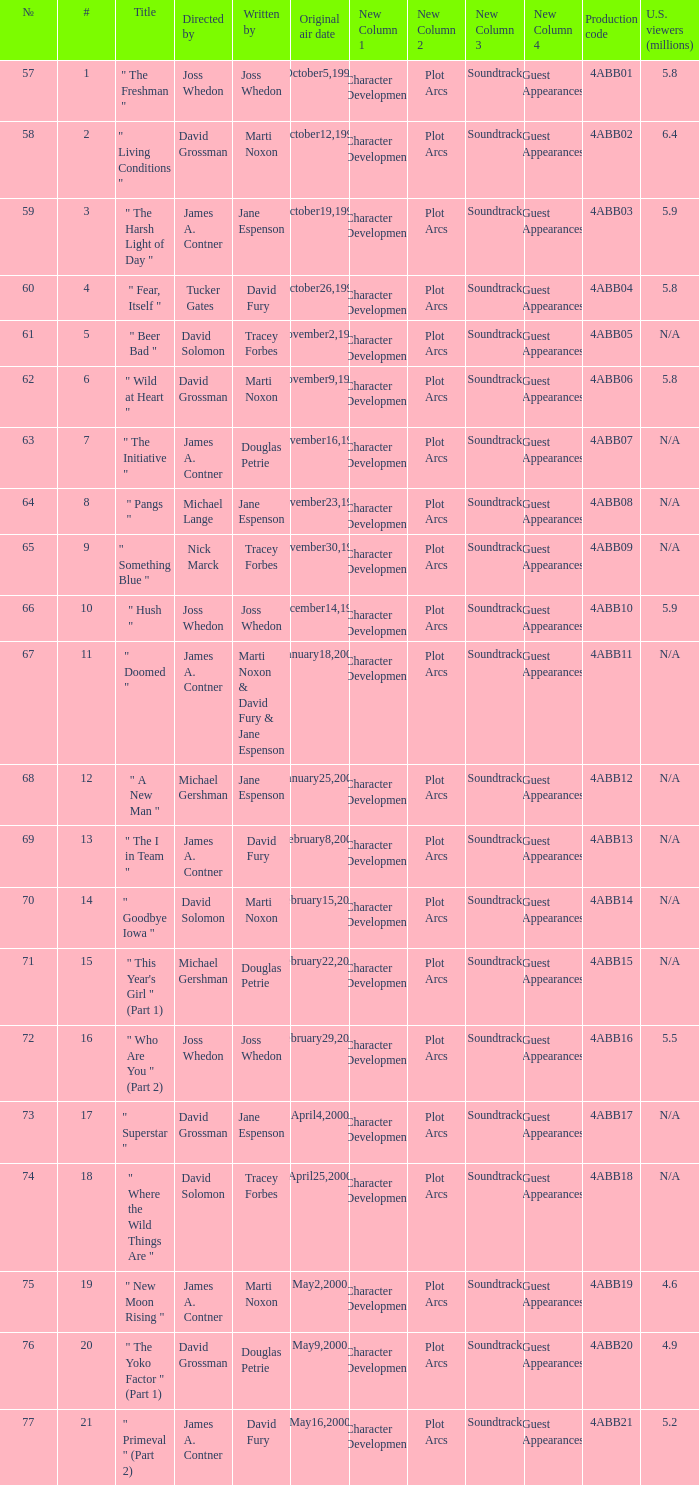What is the series No when the season 4 # is 18? 74.0. 